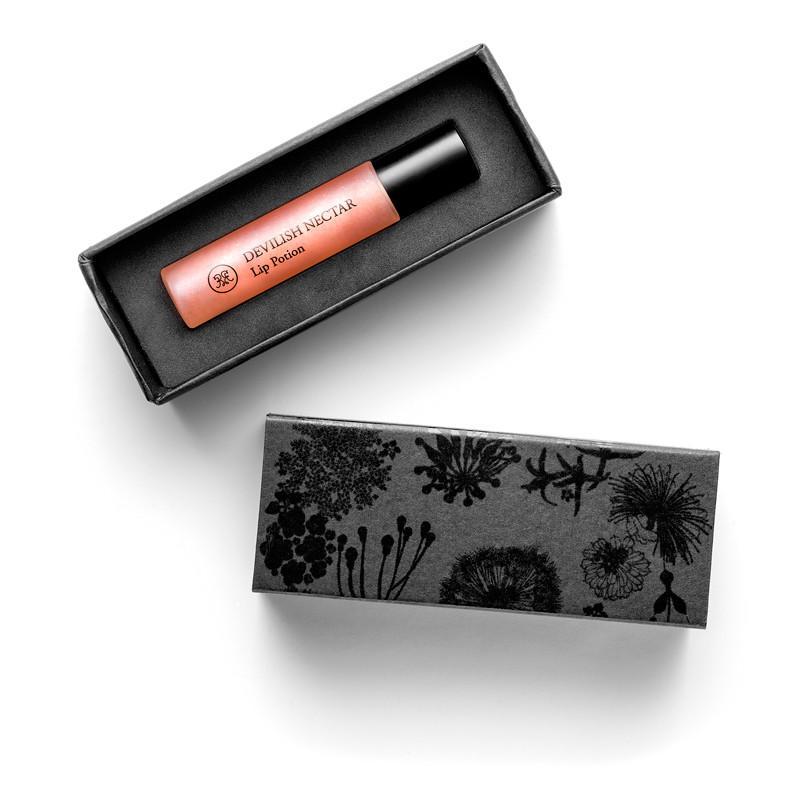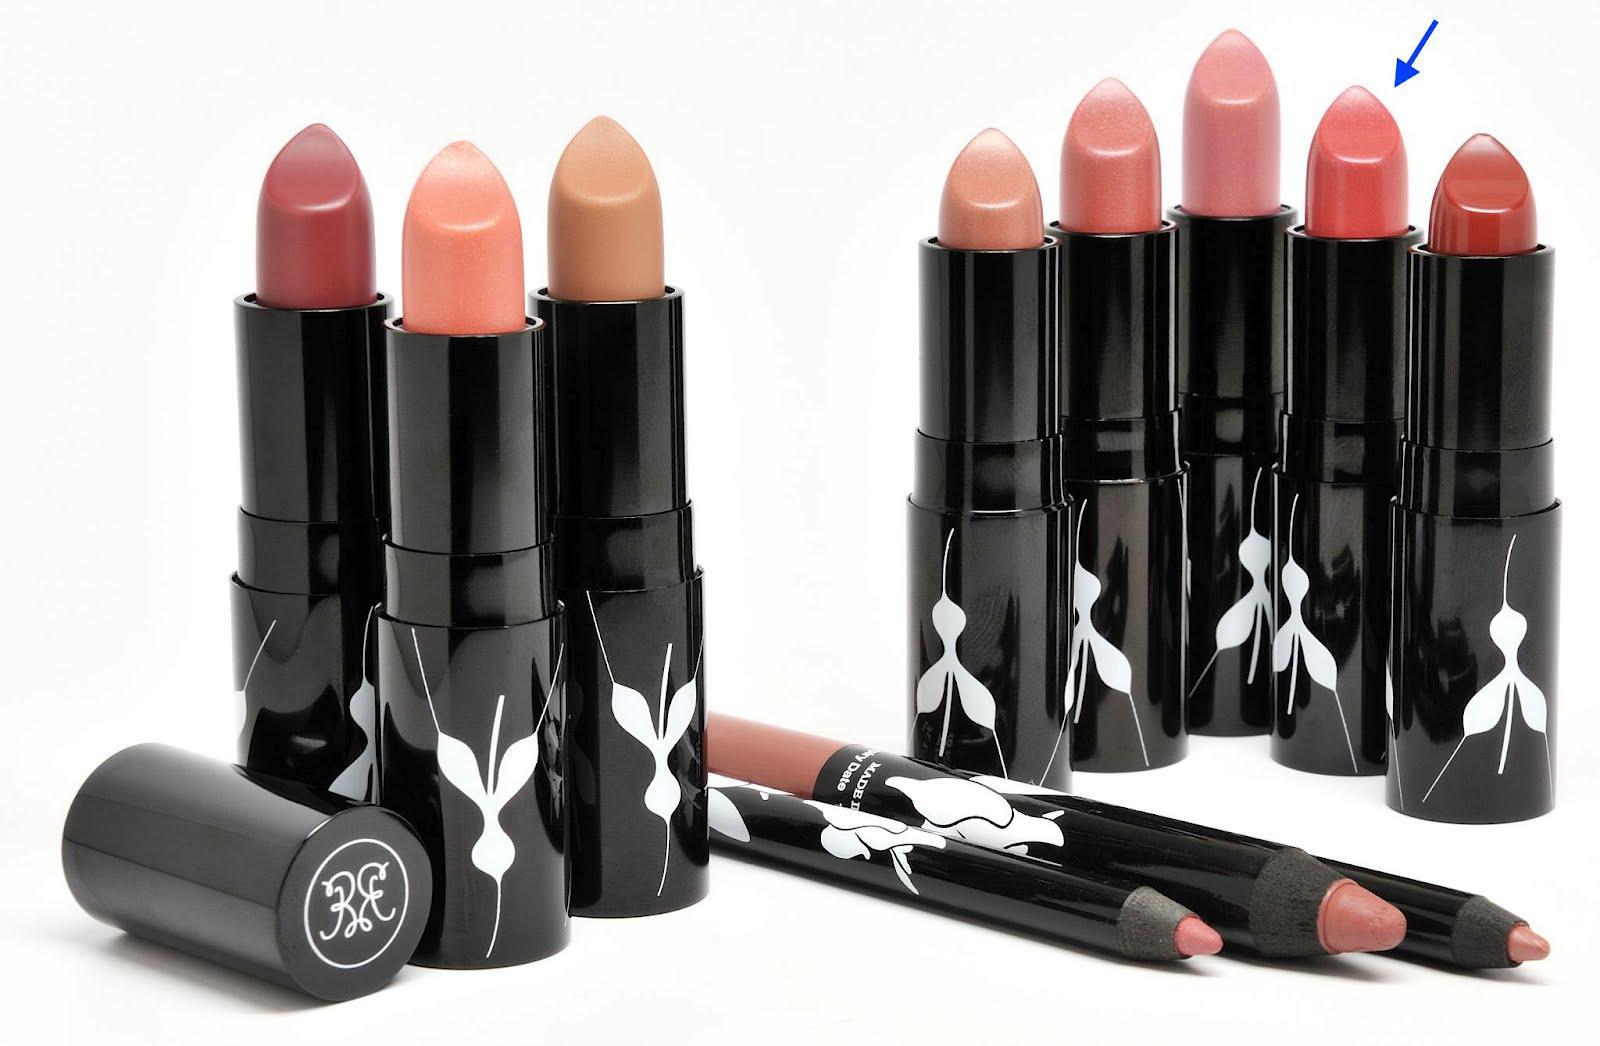The first image is the image on the left, the second image is the image on the right. Considering the images on both sides, is "In the left image, there is a single tube of makeup, and it has a clear body casing." valid? Answer yes or no. Yes. The first image is the image on the left, the second image is the image on the right. Considering the images on both sides, is "There are at least eight lip products in total." valid? Answer yes or no. Yes. 